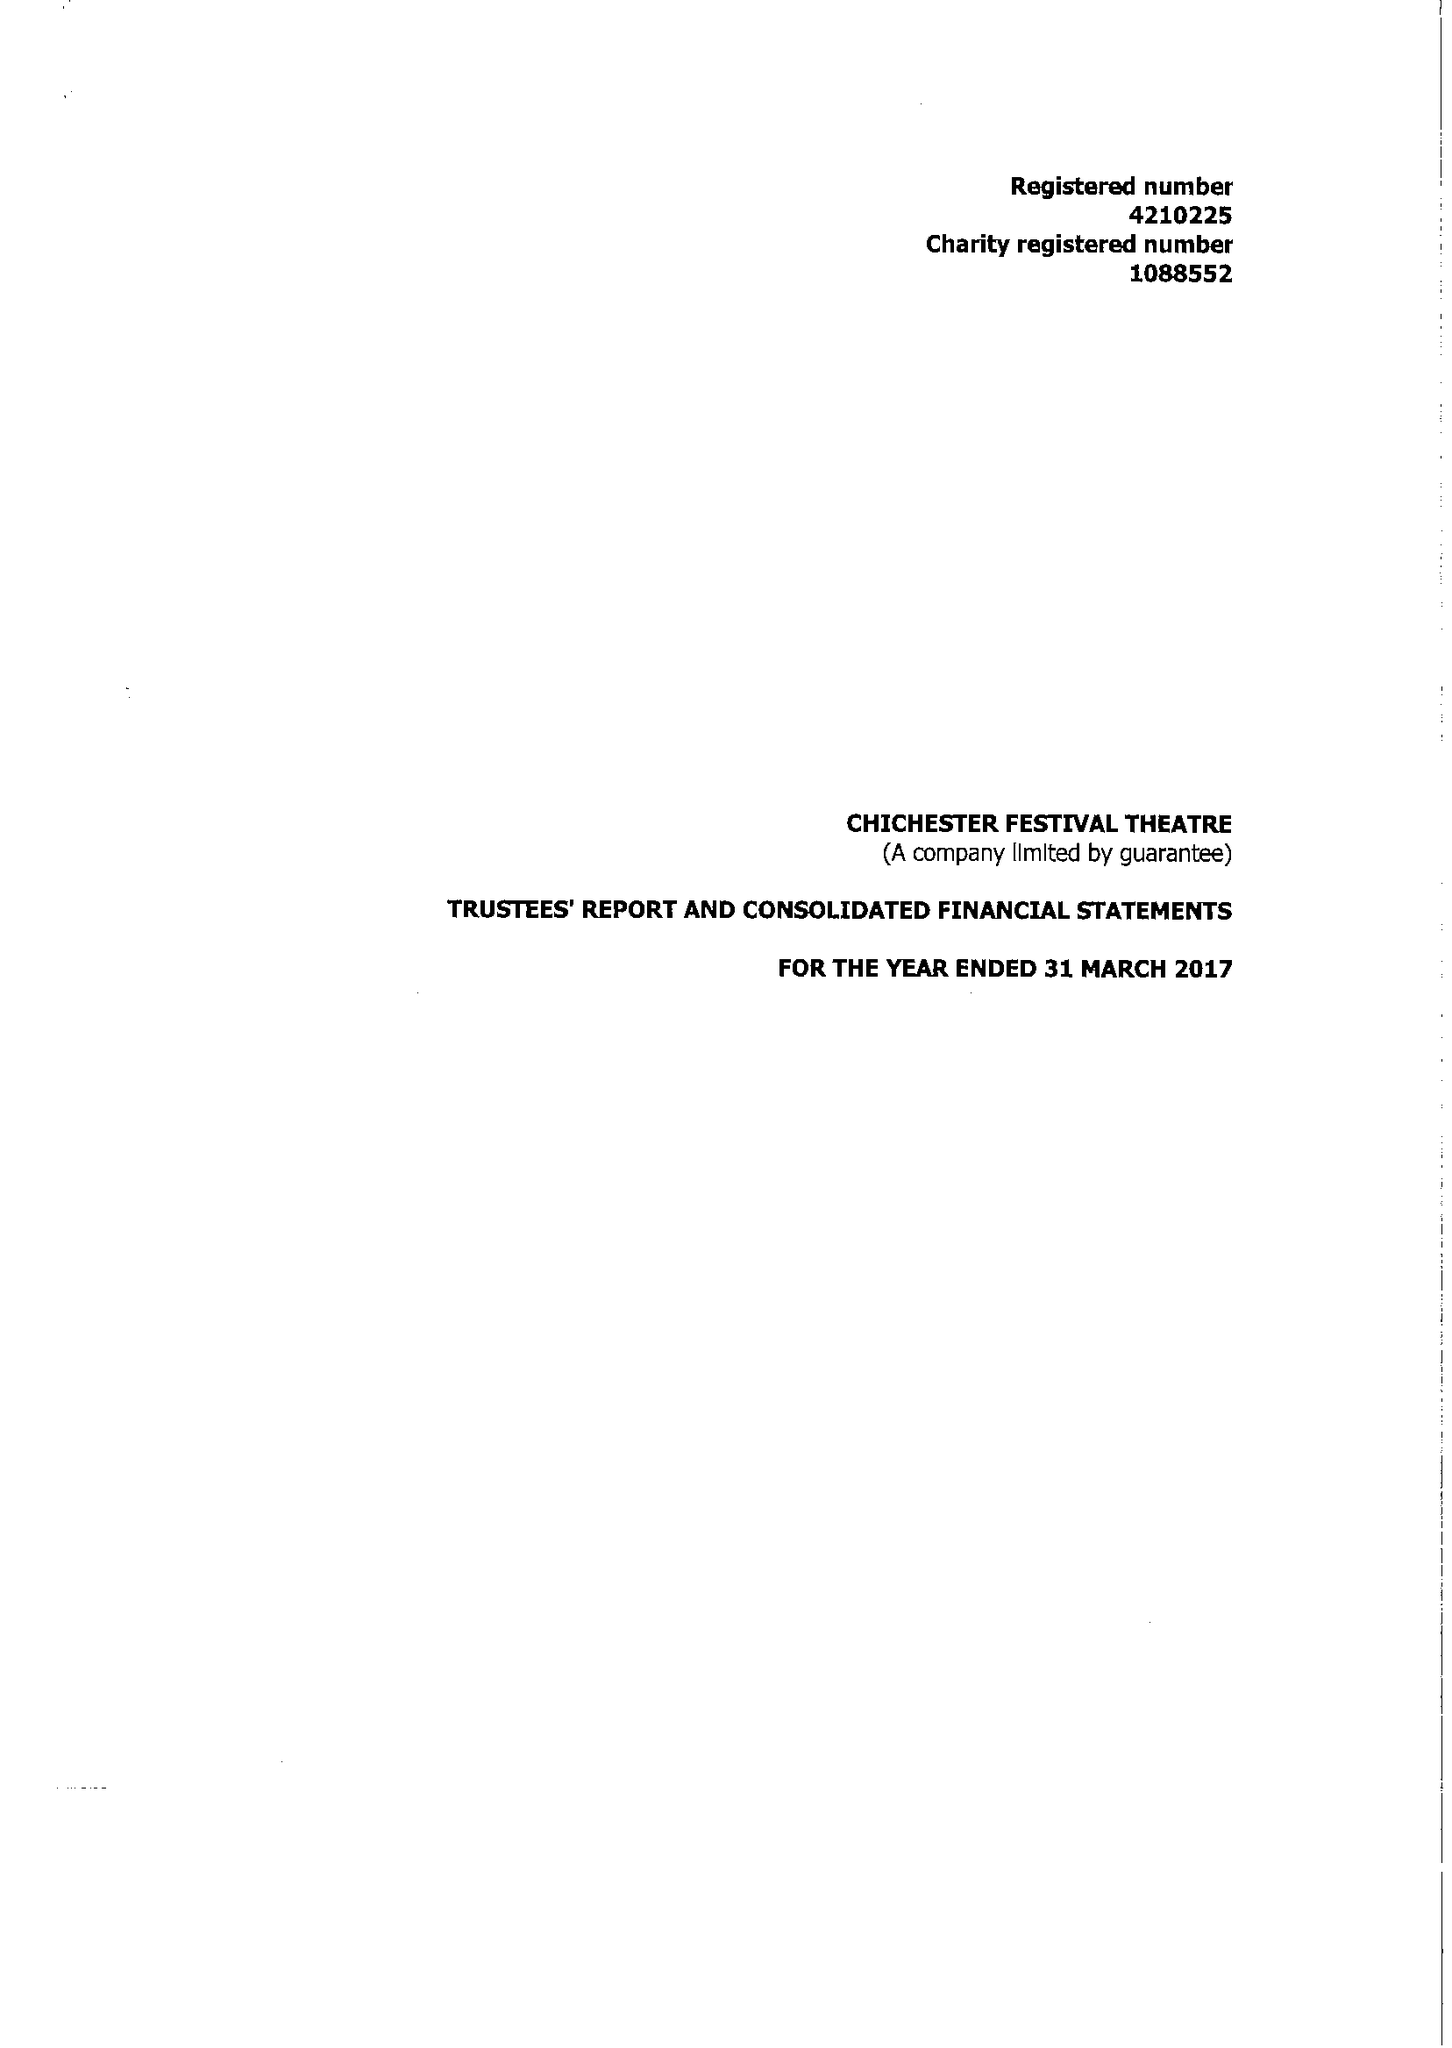What is the value for the report_date?
Answer the question using a single word or phrase. 2017-03-31 